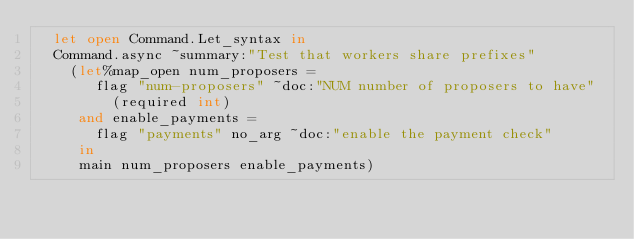Convert code to text. <code><loc_0><loc_0><loc_500><loc_500><_OCaml_>  let open Command.Let_syntax in
  Command.async ~summary:"Test that workers share prefixes"
    (let%map_open num_proposers =
       flag "num-proposers" ~doc:"NUM number of proposers to have"
         (required int)
     and enable_payments =
       flag "payments" no_arg ~doc:"enable the payment check"
     in
     main num_proposers enable_payments)
</code> 